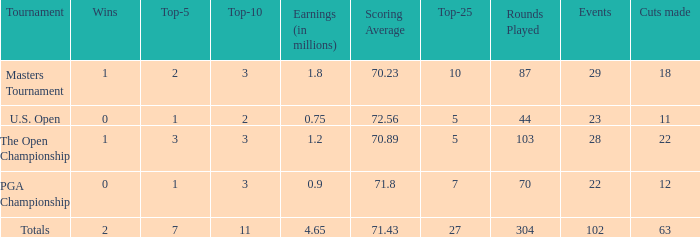How many vuts made for a player with 2 wins and under 7 top 5s? None. 